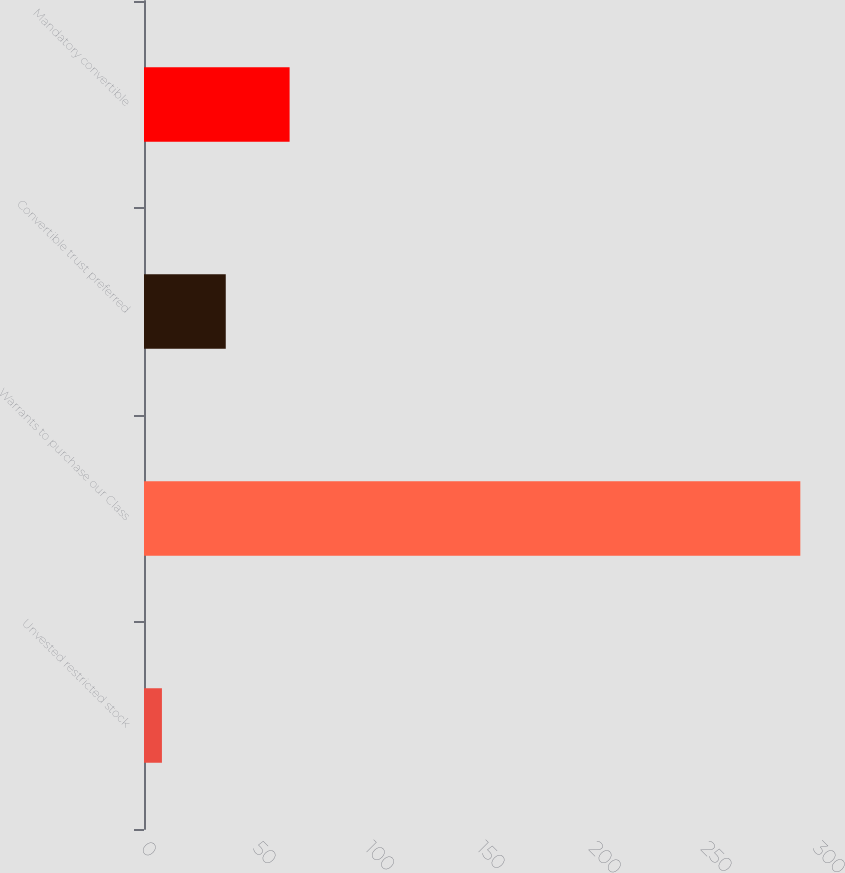Convert chart to OTSL. <chart><loc_0><loc_0><loc_500><loc_500><bar_chart><fcel>Unvested restricted stock<fcel>Warrants to purchase our Class<fcel>Convertible trust preferred<fcel>Mandatory convertible<nl><fcel>8<fcel>293<fcel>36.5<fcel>65<nl></chart> 